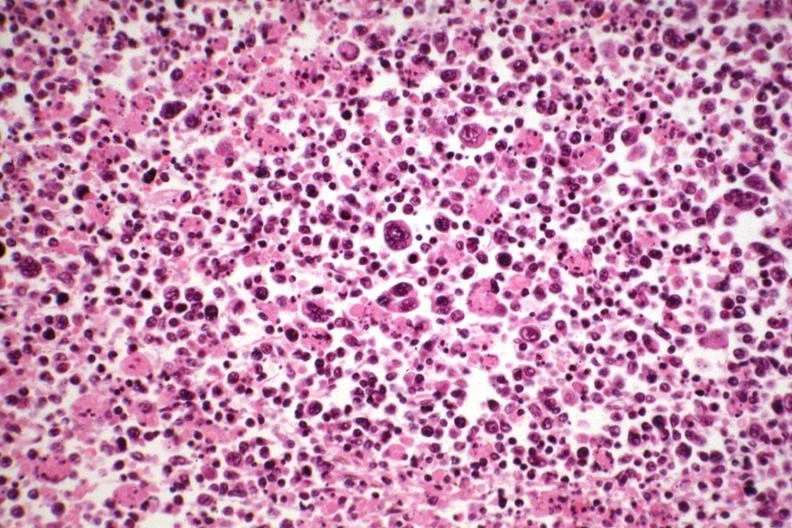what does hodgkins see?
Answer the question using a single word or phrase. Other slides in file 